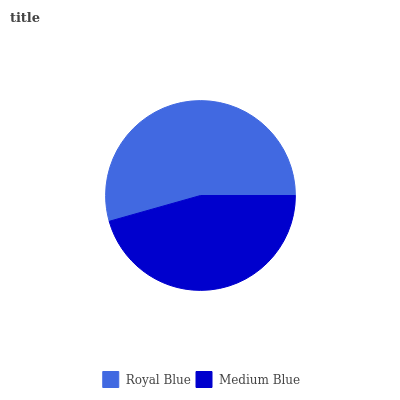Is Medium Blue the minimum?
Answer yes or no. Yes. Is Royal Blue the maximum?
Answer yes or no. Yes. Is Medium Blue the maximum?
Answer yes or no. No. Is Royal Blue greater than Medium Blue?
Answer yes or no. Yes. Is Medium Blue less than Royal Blue?
Answer yes or no. Yes. Is Medium Blue greater than Royal Blue?
Answer yes or no. No. Is Royal Blue less than Medium Blue?
Answer yes or no. No. Is Royal Blue the high median?
Answer yes or no. Yes. Is Medium Blue the low median?
Answer yes or no. Yes. Is Medium Blue the high median?
Answer yes or no. No. Is Royal Blue the low median?
Answer yes or no. No. 